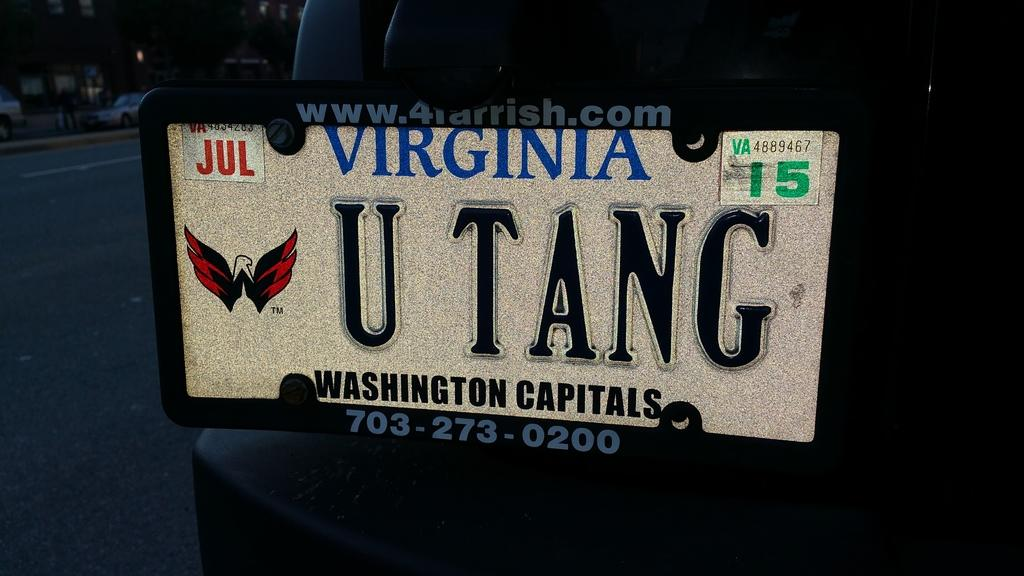<image>
Render a clear and concise summary of the photo. Virginia license vanity license plate displaying U TANG 